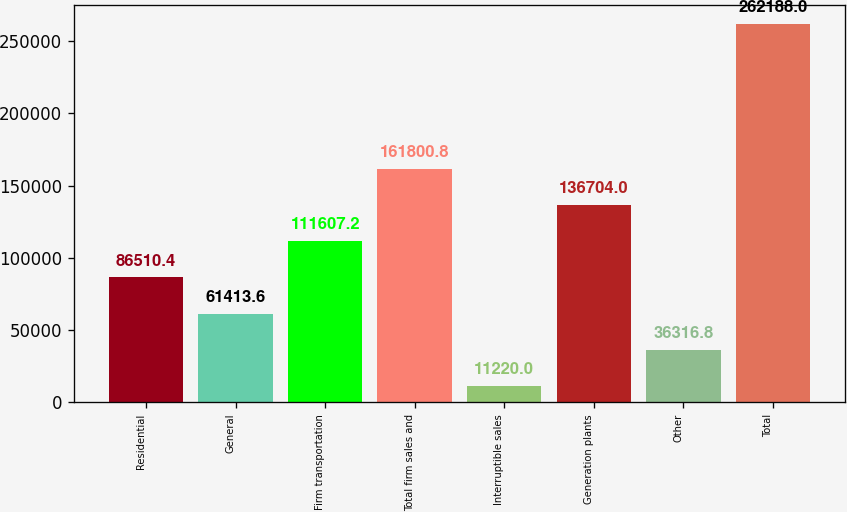<chart> <loc_0><loc_0><loc_500><loc_500><bar_chart><fcel>Residential<fcel>General<fcel>Firm transportation<fcel>Total firm sales and<fcel>Interruptible sales<fcel>Generation plants<fcel>Other<fcel>Total<nl><fcel>86510.4<fcel>61413.6<fcel>111607<fcel>161801<fcel>11220<fcel>136704<fcel>36316.8<fcel>262188<nl></chart> 